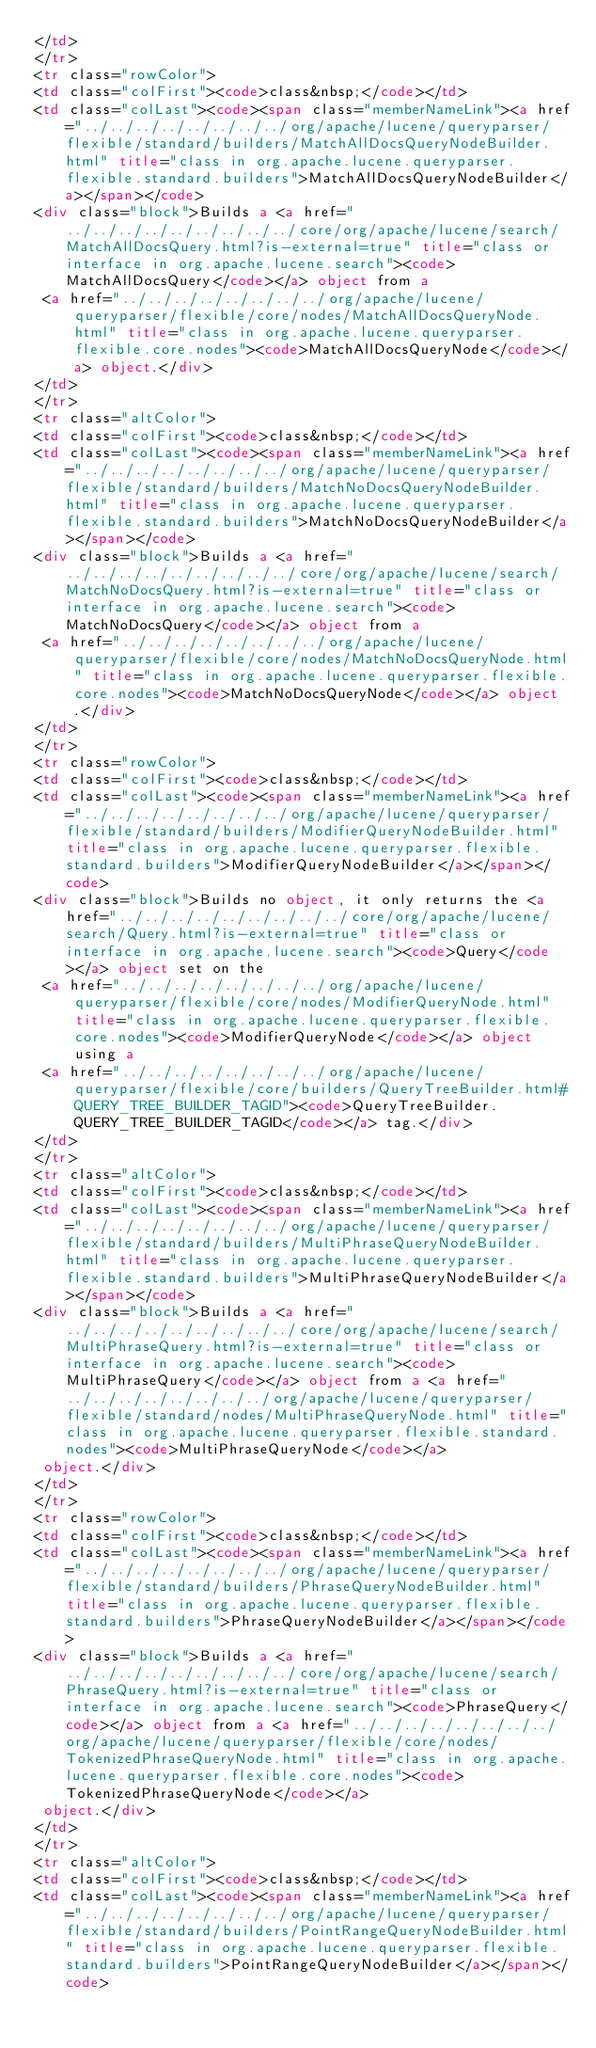Convert code to text. <code><loc_0><loc_0><loc_500><loc_500><_HTML_></td>
</tr>
<tr class="rowColor">
<td class="colFirst"><code>class&nbsp;</code></td>
<td class="colLast"><code><span class="memberNameLink"><a href="../../../../../../../../org/apache/lucene/queryparser/flexible/standard/builders/MatchAllDocsQueryNodeBuilder.html" title="class in org.apache.lucene.queryparser.flexible.standard.builders">MatchAllDocsQueryNodeBuilder</a></span></code>
<div class="block">Builds a <a href="../../../../../../../../../core/org/apache/lucene/search/MatchAllDocsQuery.html?is-external=true" title="class or interface in org.apache.lucene.search"><code>MatchAllDocsQuery</code></a> object from a
 <a href="../../../../../../../../org/apache/lucene/queryparser/flexible/core/nodes/MatchAllDocsQueryNode.html" title="class in org.apache.lucene.queryparser.flexible.core.nodes"><code>MatchAllDocsQueryNode</code></a> object.</div>
</td>
</tr>
<tr class="altColor">
<td class="colFirst"><code>class&nbsp;</code></td>
<td class="colLast"><code><span class="memberNameLink"><a href="../../../../../../../../org/apache/lucene/queryparser/flexible/standard/builders/MatchNoDocsQueryNodeBuilder.html" title="class in org.apache.lucene.queryparser.flexible.standard.builders">MatchNoDocsQueryNodeBuilder</a></span></code>
<div class="block">Builds a <a href="../../../../../../../../../core/org/apache/lucene/search/MatchNoDocsQuery.html?is-external=true" title="class or interface in org.apache.lucene.search"><code>MatchNoDocsQuery</code></a> object from a
 <a href="../../../../../../../../org/apache/lucene/queryparser/flexible/core/nodes/MatchNoDocsQueryNode.html" title="class in org.apache.lucene.queryparser.flexible.core.nodes"><code>MatchNoDocsQueryNode</code></a> object.</div>
</td>
</tr>
<tr class="rowColor">
<td class="colFirst"><code>class&nbsp;</code></td>
<td class="colLast"><code><span class="memberNameLink"><a href="../../../../../../../../org/apache/lucene/queryparser/flexible/standard/builders/ModifierQueryNodeBuilder.html" title="class in org.apache.lucene.queryparser.flexible.standard.builders">ModifierQueryNodeBuilder</a></span></code>
<div class="block">Builds no object, it only returns the <a href="../../../../../../../../../core/org/apache/lucene/search/Query.html?is-external=true" title="class or interface in org.apache.lucene.search"><code>Query</code></a> object set on the
 <a href="../../../../../../../../org/apache/lucene/queryparser/flexible/core/nodes/ModifierQueryNode.html" title="class in org.apache.lucene.queryparser.flexible.core.nodes"><code>ModifierQueryNode</code></a> object using a
 <a href="../../../../../../../../org/apache/lucene/queryparser/flexible/core/builders/QueryTreeBuilder.html#QUERY_TREE_BUILDER_TAGID"><code>QueryTreeBuilder.QUERY_TREE_BUILDER_TAGID</code></a> tag.</div>
</td>
</tr>
<tr class="altColor">
<td class="colFirst"><code>class&nbsp;</code></td>
<td class="colLast"><code><span class="memberNameLink"><a href="../../../../../../../../org/apache/lucene/queryparser/flexible/standard/builders/MultiPhraseQueryNodeBuilder.html" title="class in org.apache.lucene.queryparser.flexible.standard.builders">MultiPhraseQueryNodeBuilder</a></span></code>
<div class="block">Builds a <a href="../../../../../../../../../core/org/apache/lucene/search/MultiPhraseQuery.html?is-external=true" title="class or interface in org.apache.lucene.search"><code>MultiPhraseQuery</code></a> object from a <a href="../../../../../../../../org/apache/lucene/queryparser/flexible/standard/nodes/MultiPhraseQueryNode.html" title="class in org.apache.lucene.queryparser.flexible.standard.nodes"><code>MultiPhraseQueryNode</code></a>
 object.</div>
</td>
</tr>
<tr class="rowColor">
<td class="colFirst"><code>class&nbsp;</code></td>
<td class="colLast"><code><span class="memberNameLink"><a href="../../../../../../../../org/apache/lucene/queryparser/flexible/standard/builders/PhraseQueryNodeBuilder.html" title="class in org.apache.lucene.queryparser.flexible.standard.builders">PhraseQueryNodeBuilder</a></span></code>
<div class="block">Builds a <a href="../../../../../../../../../core/org/apache/lucene/search/PhraseQuery.html?is-external=true" title="class or interface in org.apache.lucene.search"><code>PhraseQuery</code></a> object from a <a href="../../../../../../../../org/apache/lucene/queryparser/flexible/core/nodes/TokenizedPhraseQueryNode.html" title="class in org.apache.lucene.queryparser.flexible.core.nodes"><code>TokenizedPhraseQueryNode</code></a>
 object.</div>
</td>
</tr>
<tr class="altColor">
<td class="colFirst"><code>class&nbsp;</code></td>
<td class="colLast"><code><span class="memberNameLink"><a href="../../../../../../../../org/apache/lucene/queryparser/flexible/standard/builders/PointRangeQueryNodeBuilder.html" title="class in org.apache.lucene.queryparser.flexible.standard.builders">PointRangeQueryNodeBuilder</a></span></code></code> 